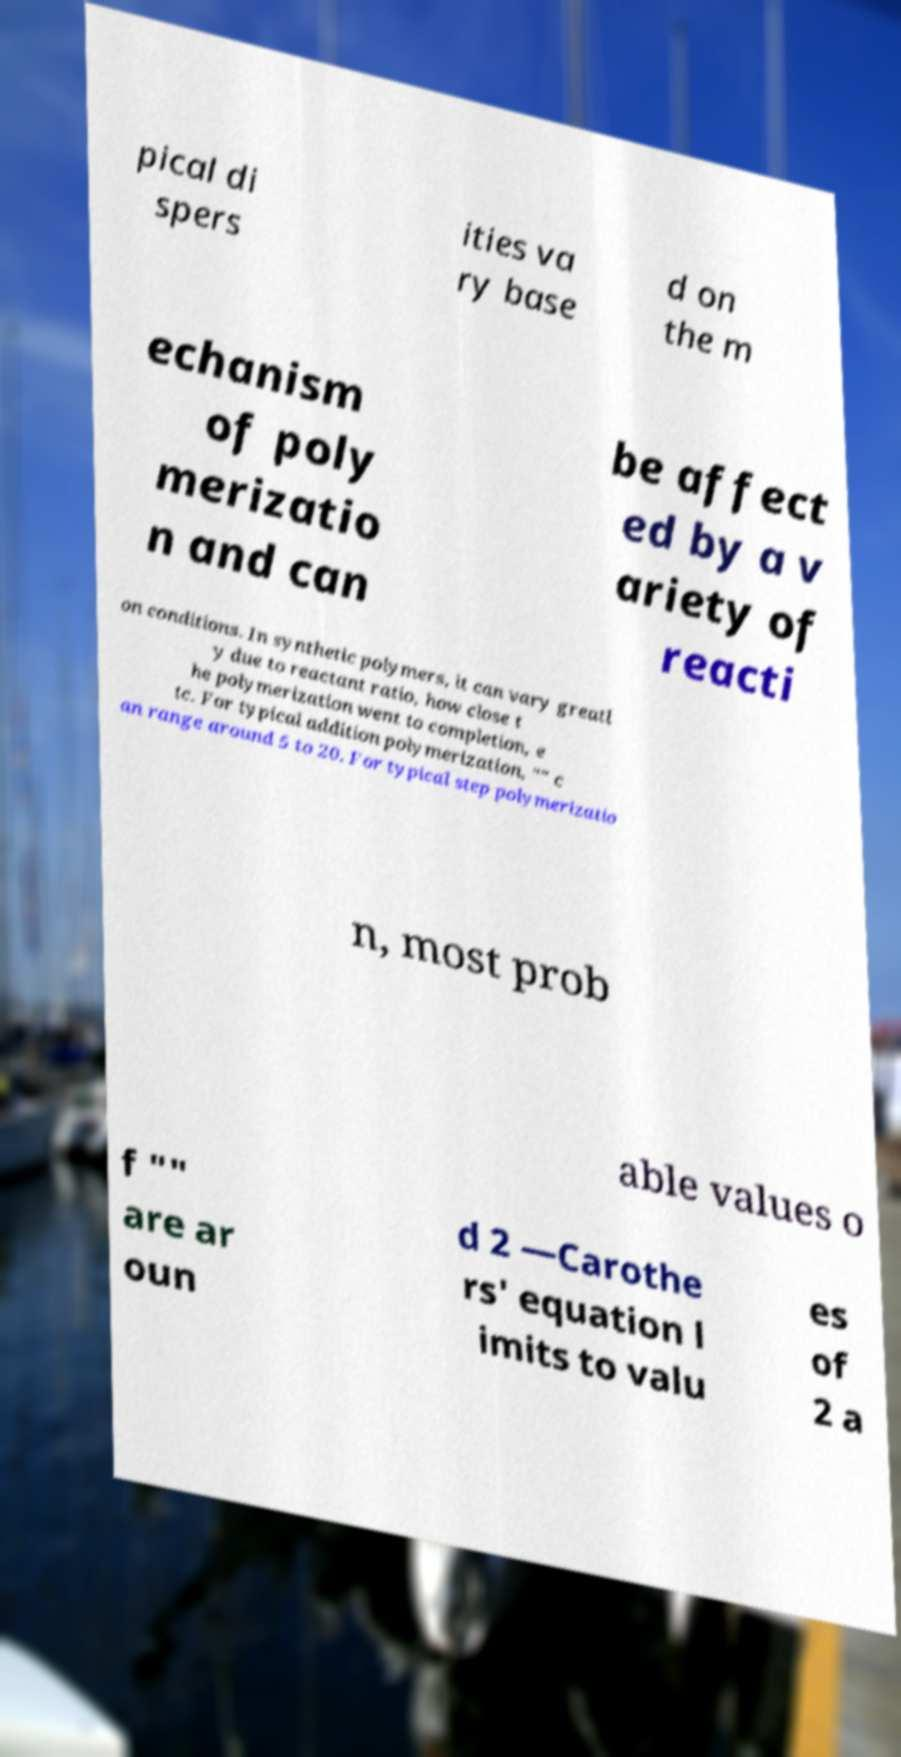Please identify and transcribe the text found in this image. pical di spers ities va ry base d on the m echanism of poly merizatio n and can be affect ed by a v ariety of reacti on conditions. In synthetic polymers, it can vary greatl y due to reactant ratio, how close t he polymerization went to completion, e tc. For typical addition polymerization, "" c an range around 5 to 20. For typical step polymerizatio n, most prob able values o f "" are ar oun d 2 —Carothe rs' equation l imits to valu es of 2 a 